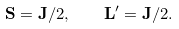Convert formula to latex. <formula><loc_0><loc_0><loc_500><loc_500>\mathbf S = \mathbf J / 2 , \quad \mathbf L ^ { \prime } = \mathbf J / 2 .</formula> 